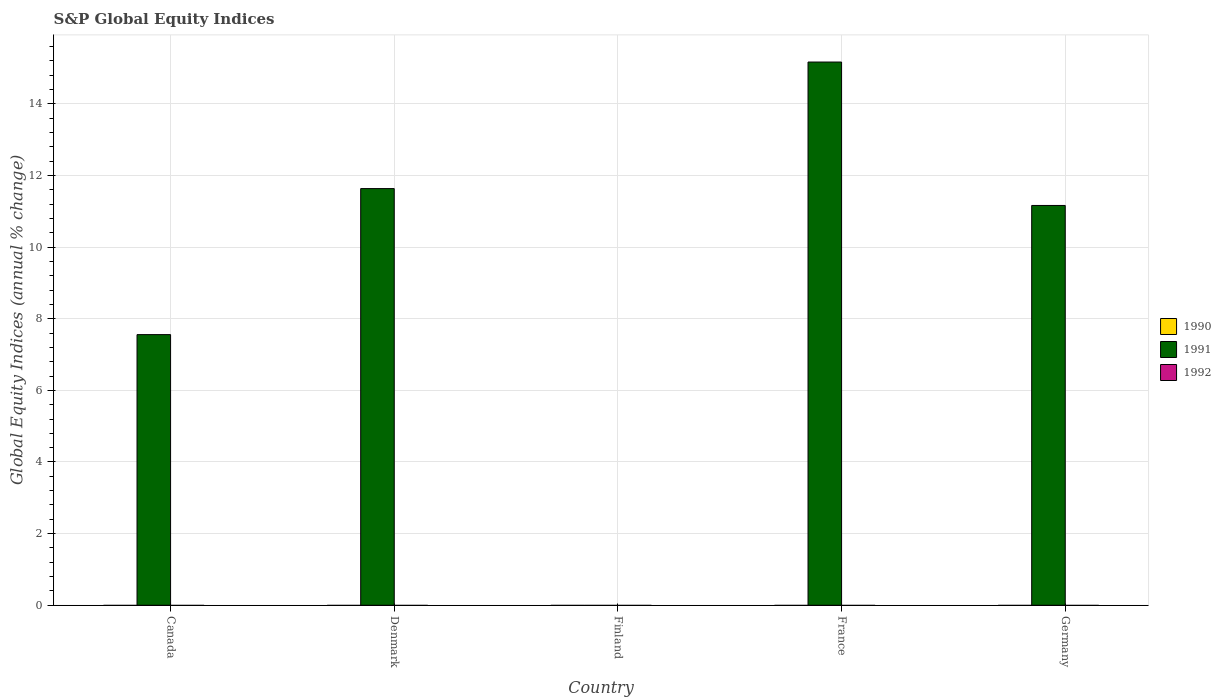How many different coloured bars are there?
Provide a short and direct response. 1. Are the number of bars per tick equal to the number of legend labels?
Your answer should be compact. No. What is the label of the 3rd group of bars from the left?
Offer a very short reply. Finland. What is the global equity indices in 1991 in Canada?
Give a very brief answer. 7.56. Across all countries, what is the maximum global equity indices in 1991?
Give a very brief answer. 15.17. Across all countries, what is the minimum global equity indices in 1990?
Give a very brief answer. 0. In which country was the global equity indices in 1991 maximum?
Give a very brief answer. France. What is the difference between the global equity indices in 1991 in Canada and that in France?
Ensure brevity in your answer.  -7.61. What is the difference between the global equity indices in 1991 in Germany and the global equity indices in 1990 in France?
Give a very brief answer. 11.16. What is the average global equity indices in 1991 per country?
Your response must be concise. 9.1. What is the ratio of the global equity indices in 1991 in Canada to that in Denmark?
Offer a very short reply. 0.65. Is the global equity indices in 1991 in Canada less than that in Germany?
Offer a very short reply. Yes. What is the difference between the highest and the second highest global equity indices in 1991?
Offer a terse response. -0.47. What is the difference between the highest and the lowest global equity indices in 1991?
Offer a very short reply. 15.17. In how many countries, is the global equity indices in 1992 greater than the average global equity indices in 1992 taken over all countries?
Make the answer very short. 0. How many bars are there?
Your answer should be very brief. 4. What is the difference between two consecutive major ticks on the Y-axis?
Keep it short and to the point. 2. Does the graph contain any zero values?
Provide a short and direct response. Yes. What is the title of the graph?
Offer a very short reply. S&P Global Equity Indices. What is the label or title of the Y-axis?
Ensure brevity in your answer.  Global Equity Indices (annual % change). What is the Global Equity Indices (annual % change) of 1990 in Canada?
Ensure brevity in your answer.  0. What is the Global Equity Indices (annual % change) of 1991 in Canada?
Your answer should be compact. 7.56. What is the Global Equity Indices (annual % change) of 1992 in Canada?
Your response must be concise. 0. What is the Global Equity Indices (annual % change) in 1990 in Denmark?
Your response must be concise. 0. What is the Global Equity Indices (annual % change) of 1991 in Denmark?
Keep it short and to the point. 11.63. What is the Global Equity Indices (annual % change) in 1991 in Finland?
Offer a terse response. 0. What is the Global Equity Indices (annual % change) in 1991 in France?
Your answer should be compact. 15.17. What is the Global Equity Indices (annual % change) of 1991 in Germany?
Keep it short and to the point. 11.16. Across all countries, what is the maximum Global Equity Indices (annual % change) of 1991?
Your response must be concise. 15.17. Across all countries, what is the minimum Global Equity Indices (annual % change) of 1991?
Your answer should be very brief. 0. What is the total Global Equity Indices (annual % change) of 1991 in the graph?
Keep it short and to the point. 45.52. What is the difference between the Global Equity Indices (annual % change) in 1991 in Canada and that in Denmark?
Your answer should be compact. -4.08. What is the difference between the Global Equity Indices (annual % change) in 1991 in Canada and that in France?
Make the answer very short. -7.61. What is the difference between the Global Equity Indices (annual % change) of 1991 in Canada and that in Germany?
Offer a very short reply. -3.61. What is the difference between the Global Equity Indices (annual % change) of 1991 in Denmark and that in France?
Keep it short and to the point. -3.53. What is the difference between the Global Equity Indices (annual % change) in 1991 in Denmark and that in Germany?
Offer a very short reply. 0.47. What is the difference between the Global Equity Indices (annual % change) in 1991 in France and that in Germany?
Provide a short and direct response. 4. What is the average Global Equity Indices (annual % change) in 1991 per country?
Offer a terse response. 9.1. What is the average Global Equity Indices (annual % change) of 1992 per country?
Offer a very short reply. 0. What is the ratio of the Global Equity Indices (annual % change) in 1991 in Canada to that in Denmark?
Your answer should be very brief. 0.65. What is the ratio of the Global Equity Indices (annual % change) in 1991 in Canada to that in France?
Offer a very short reply. 0.5. What is the ratio of the Global Equity Indices (annual % change) in 1991 in Canada to that in Germany?
Offer a very short reply. 0.68. What is the ratio of the Global Equity Indices (annual % change) of 1991 in Denmark to that in France?
Provide a short and direct response. 0.77. What is the ratio of the Global Equity Indices (annual % change) in 1991 in Denmark to that in Germany?
Make the answer very short. 1.04. What is the ratio of the Global Equity Indices (annual % change) of 1991 in France to that in Germany?
Your answer should be very brief. 1.36. What is the difference between the highest and the second highest Global Equity Indices (annual % change) of 1991?
Ensure brevity in your answer.  3.53. What is the difference between the highest and the lowest Global Equity Indices (annual % change) of 1991?
Offer a very short reply. 15.17. 